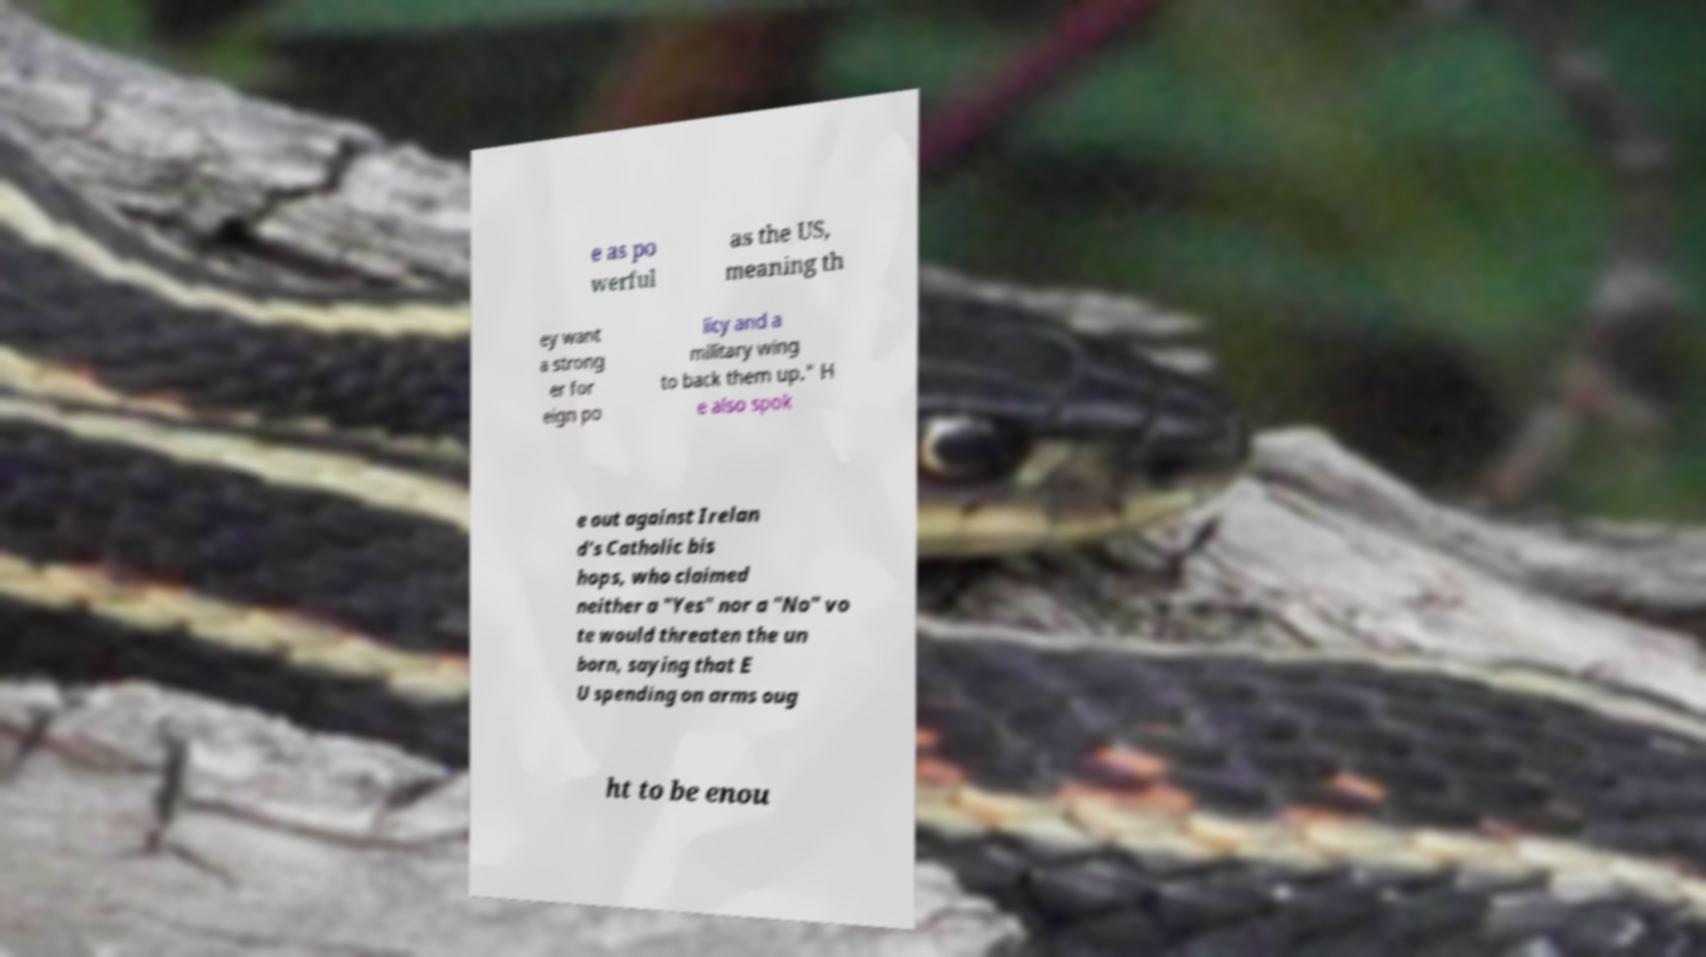Please read and relay the text visible in this image. What does it say? e as po werful as the US, meaning th ey want a strong er for eign po licy and a military wing to back them up." H e also spok e out against Irelan d's Catholic bis hops, who claimed neither a "Yes" nor a "No" vo te would threaten the un born, saying that E U spending on arms oug ht to be enou 